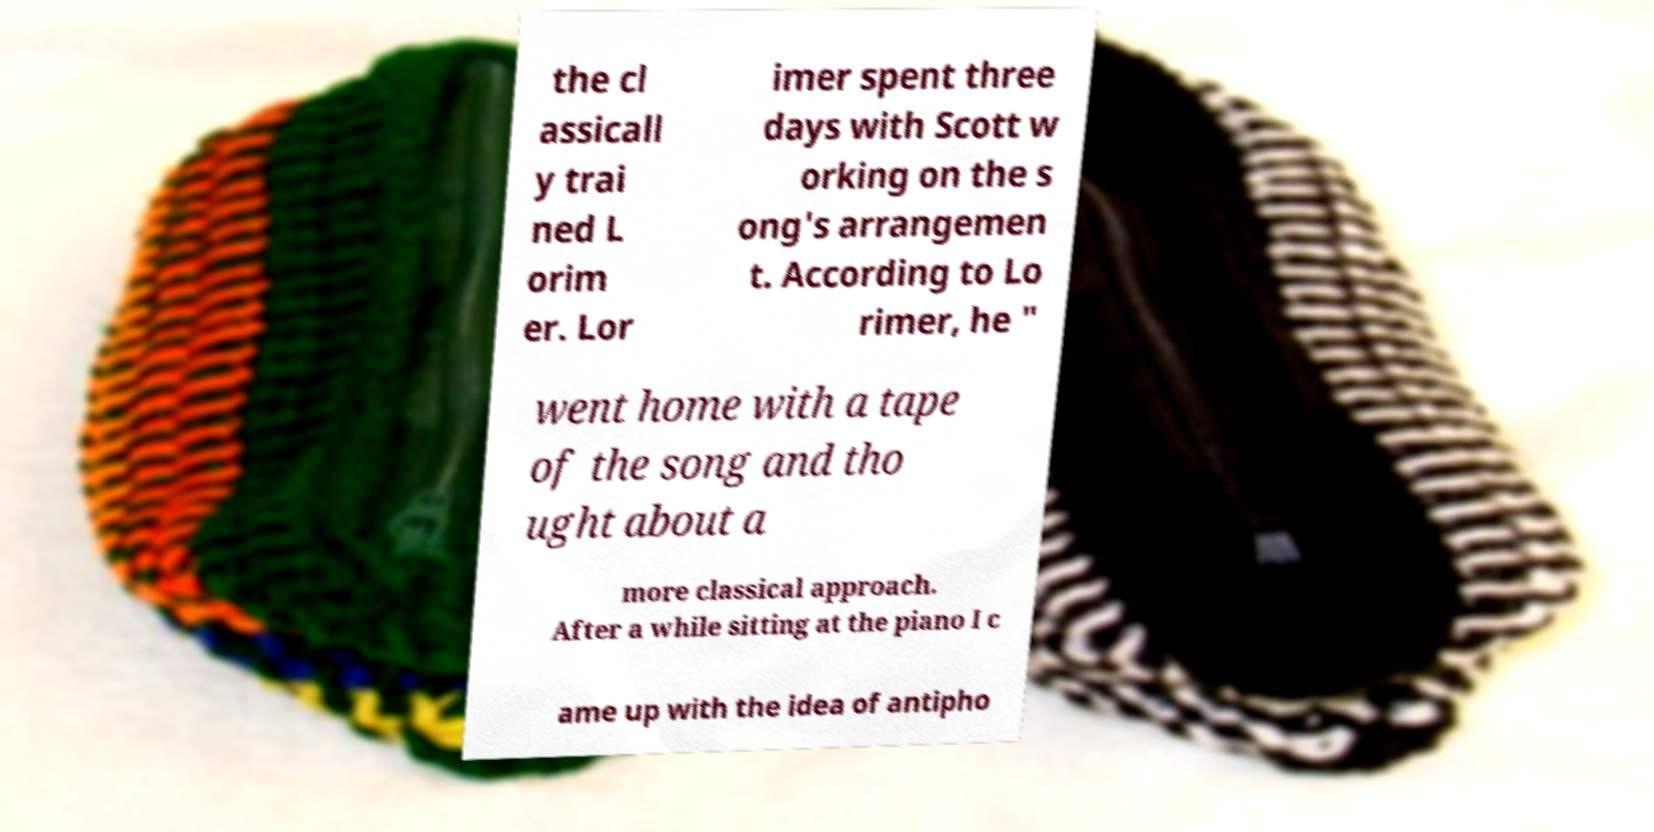Could you extract and type out the text from this image? the cl assicall y trai ned L orim er. Lor imer spent three days with Scott w orking on the s ong's arrangemen t. According to Lo rimer, he " went home with a tape of the song and tho ught about a more classical approach. After a while sitting at the piano I c ame up with the idea of antipho 